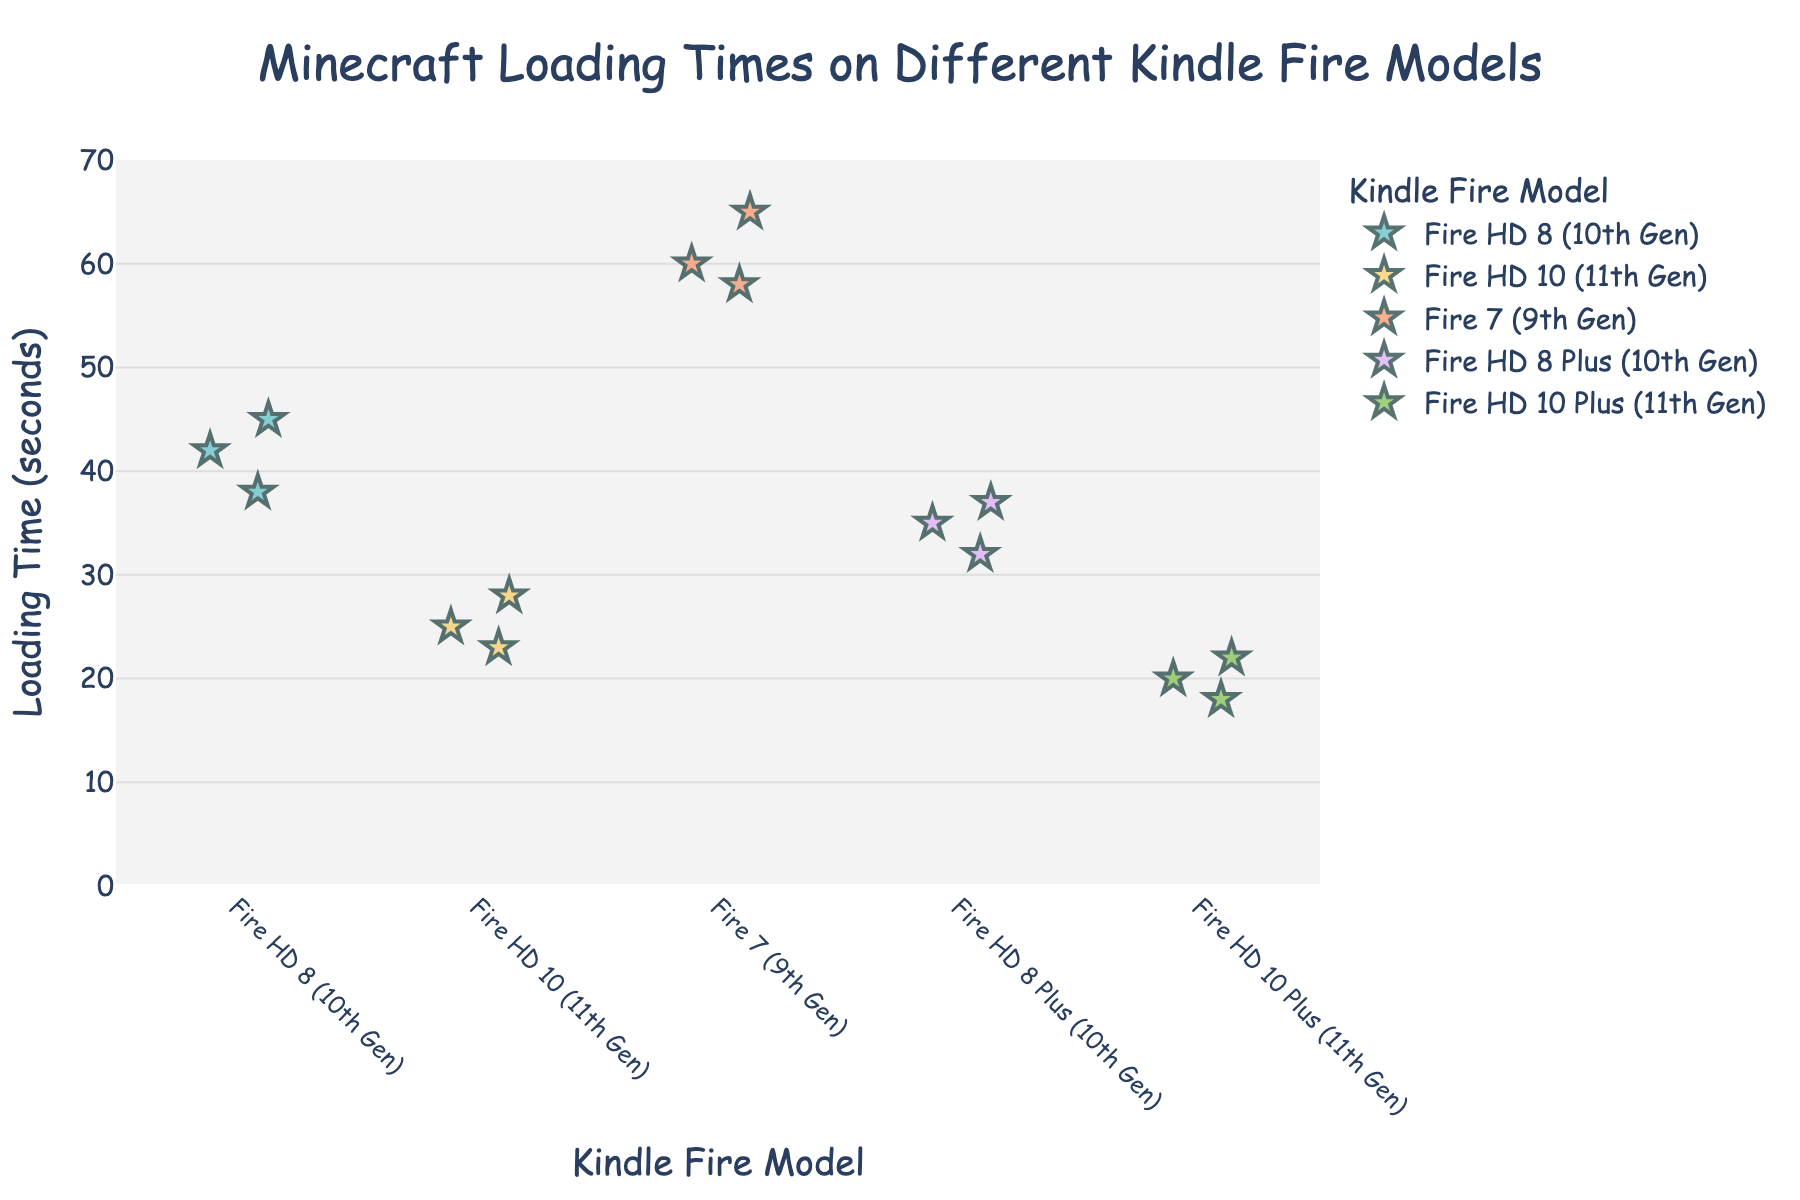what is the title of the figure? The title is located at the top of the figure, and it summarizes the information displayed in the plot.
Answer: Minecraft Loading Times on Different Kindle Fire Models What are the units labeled on the y-axis? The y-axis label indicates the units of measurement for the data on this axis.
Answer: Loading Time (seconds) How many data points are there for the Fire 7 (9th Gen) model? By counting the individual markers associated with the "Fire 7 (9th Gen)" on the x-axis, we can determine the number of data points.
Answer: 3 Which Kindle model has the shortest loading time? To determine this, identify the data point with the lowest value on the y-axis and check its corresponding Kindle model.
Answer: Fire HD 10 Plus (11th Gen) What is the average loading time for the Fire HD 8 (10th Gen)? Add up all data points for "Fire HD 8 (10th Gen)" (42 + 38 + 45) and divide by the total number of data points (3).
Answer: 41.67 Which Kindle model has the most spread in loading times? Compare the range (max - min) of loading times for each Kindle model to identify the one with the largest spread.
Answer: Fire 7 (9th Gen) Is the loading time for the Fire HD 10 (11th Gen) generally less than that for the Fire HD 8 (10th Gen)? Compare the range of loading times for both models: Fire HD 10 (11th Gen) has 23-28 seconds, while Fire HD 8 (10th Gen) has 38-45 seconds.
Answer: Yes What's the difference between the shortest loading time of the Fire HD 10 Plus (11th Gen) and the longest loading time of the Fire 7 (9th Gen)? Subtract the shortest loading time of Fire HD 10 Plus (11th Gen) (18 seconds) from the longest loading time of Fire 7 (9th Gen) (65 seconds).
Answer: 47 How many Kindle models are compared in the plot? Count the distinct Kindle models listed on the x-axis.
Answer: 5 Which Kindle model has the second-fastest average loading time? Calculate the average loading times for all models and compare them. The second-fastest average is found after identifying the fastest.
Answer: Fire HD 10 (11th Gen) 